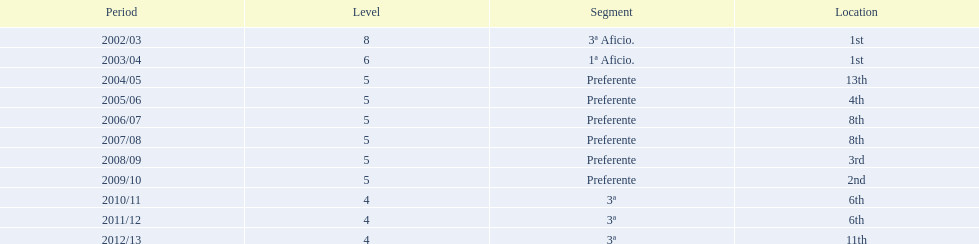Which division placed more than aficio 1a and 3a? Preferente. 